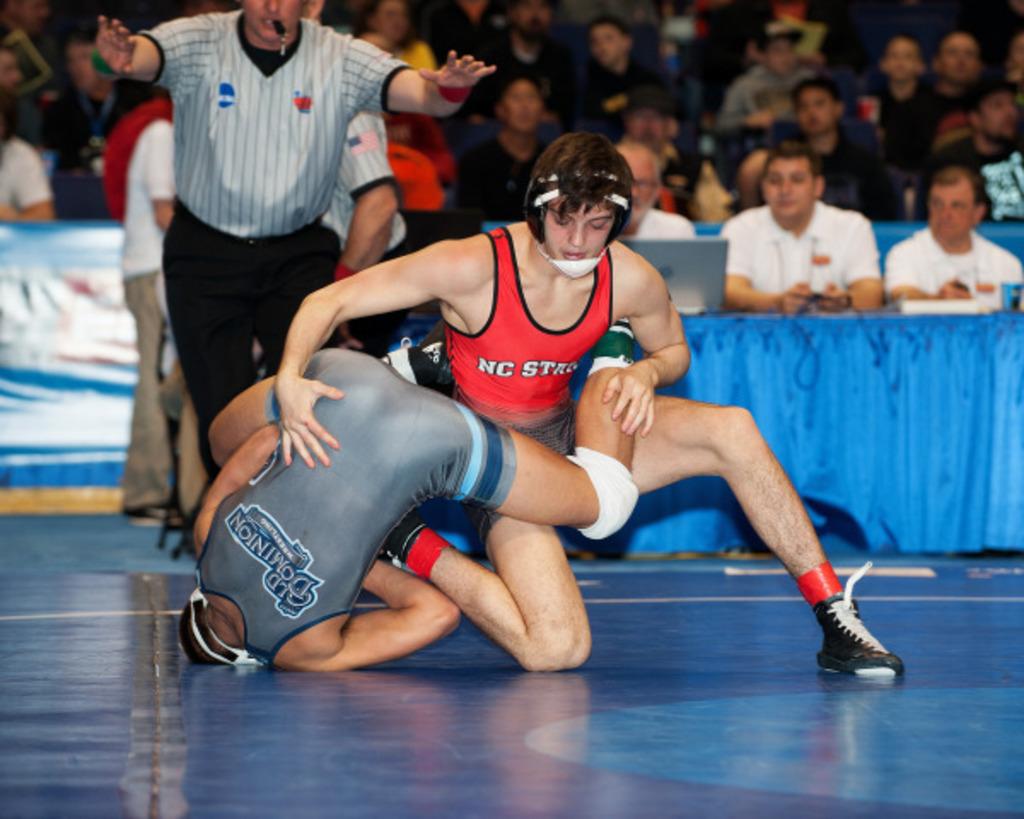What school is wrestling in the red outfit?
Ensure brevity in your answer.  Nc state. What is written on the grey outfit?
Give a very brief answer. Old dominion. 